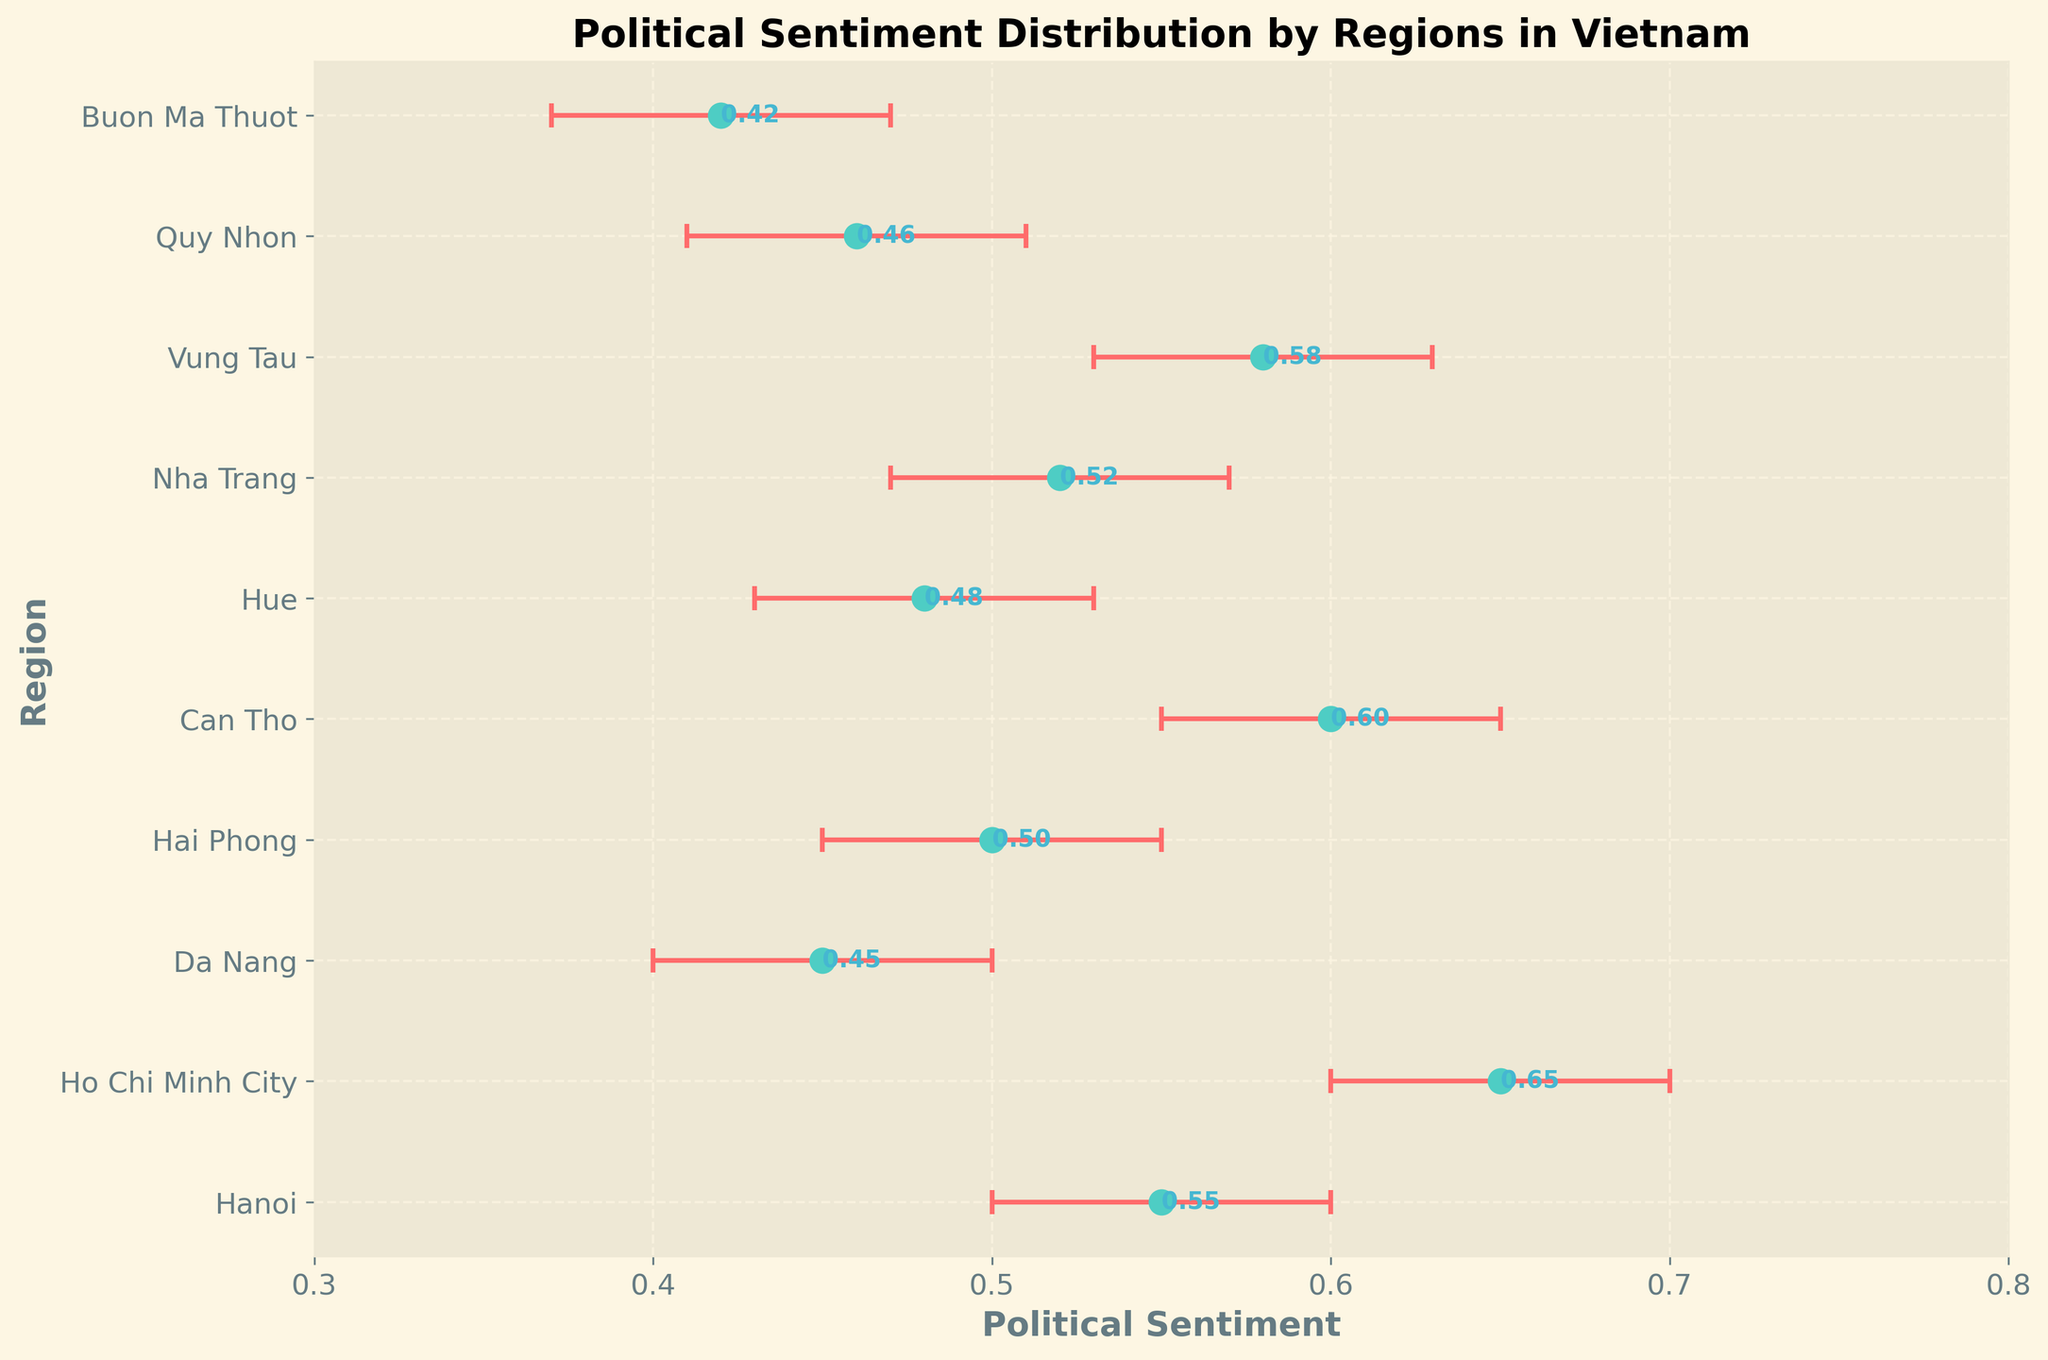What is the political sentiment in Ho Chi Minh City? The dot for Ho Chi Minh City corresponds to a political sentiment value. Locate 'Ho Chi Minh City' on the y-axis and read off the sentiment value directly from the corresponding dot.
Answer: 0.65 Which region has the highest political sentiment? Compare all the sentiment values shown by the dots across all regions. Look for the region with the highest dot value.
Answer: Ho Chi Minh City What is the range of the confidence interval for Hanoi? Identify the confidence interval for Hanoi by finding the upper and lower bounds (the endpoints of the error bar). The range is the difference between the upper and lower bounds.
Answer: 0.10 How does the political sentiment in Hai Phong compare to Can Tho? Identify the positions of the dots for Hai Phong and Can Tho. Compare their respective values to determine which is higher.
Answer: Hai Phong: 0.50, Can Tho: 0.60; Can Tho is higher What is the average political sentiment across all the regions? Add all the political sentiment values and divide by the number of regions. Summing all values: (0.55 + 0.65 + 0.45 + 0.50 + 0.60 + 0.48 + 0.52 + 0.58 + 0.46 + 0.42) = 4.81, Number of regions: 10, Average = 4.81 / 10
Answer: 0.481 Which city has the smallest confidence interval range? Calculate the confidence interval range (upper bound - lower bound) for each region and identify the minimum.
Answer: Da Nang: 0.10, smallest among all regions Which regions have political sentiments above the average sentiment (0.481)? Compare the sentiment values of each region to the average sentiment calculated earlier. Identify all regions where the sentiment is greater than 0.481.
Answer: Hanoi, Ho Chi Minh City, Can Tho, Vung Tau, Nha Trang What regions have overlapping confidence intervals? For regions to have overlapping confidence intervals, one region's upper bound must be above the other’s lower bound or vice versa. Compare all pairs based on their confidence intervals.
Answer: Hanoi & Hai Phong, Hanoi & Nha Trang, Ho Chi Minh City & Can Tho, Can Tho & Vung Tau 